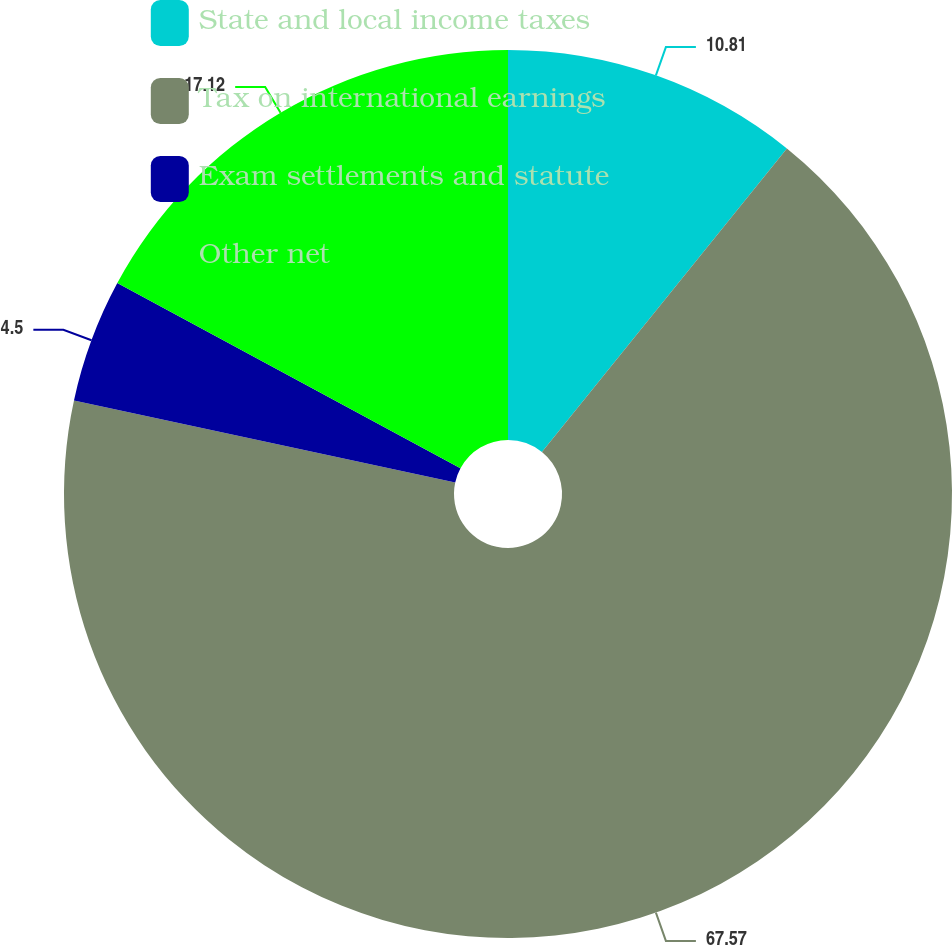Convert chart to OTSL. <chart><loc_0><loc_0><loc_500><loc_500><pie_chart><fcel>State and local income taxes<fcel>Tax on international earnings<fcel>Exam settlements and statute<fcel>Other net<nl><fcel>10.81%<fcel>67.57%<fcel>4.5%<fcel>17.12%<nl></chart> 